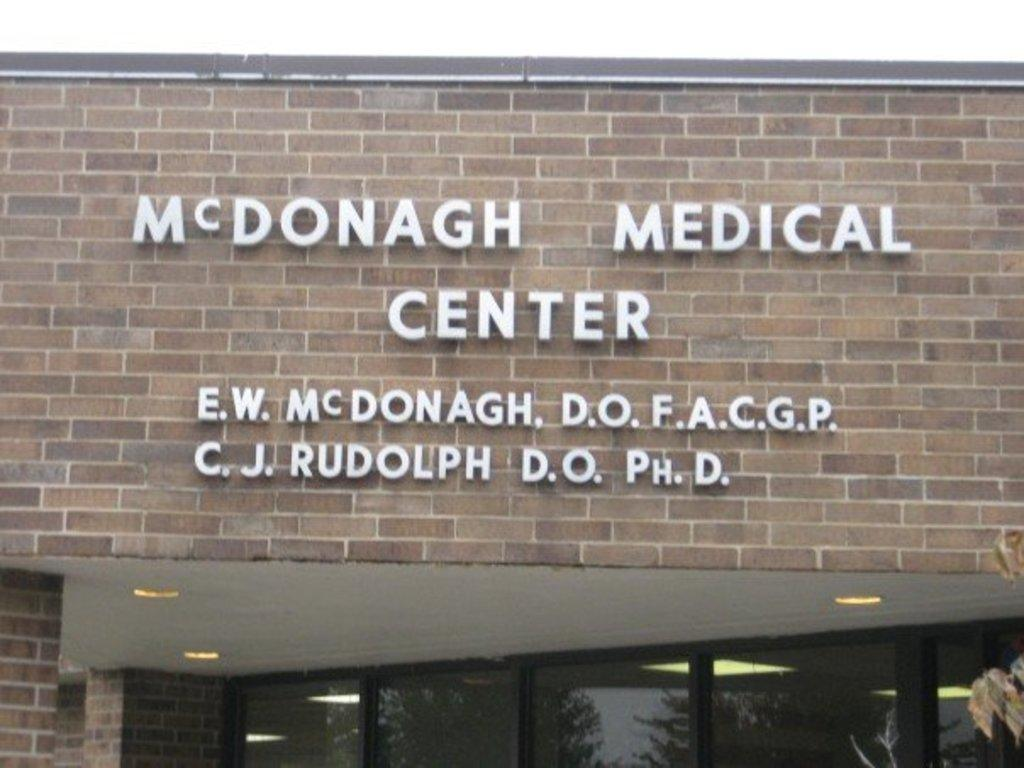What is written or displayed on the building in the image? There are letters on a building in the image. What type of vegetation is at the bottom of the image? There is a tree at the bottom of the image. What can be used to enter or exit the building in the image? There is a door at the bottom of the image. What can be seen in the distance in the image? The sky is visible in the background of the image. How many chickens are perched on the tree in the image? There are no chickens present in the image; it features a tree and a building with letters. What type of apparel is being worn by the tree in the image? There is no apparel present in the image, as trees do not wear clothing. 